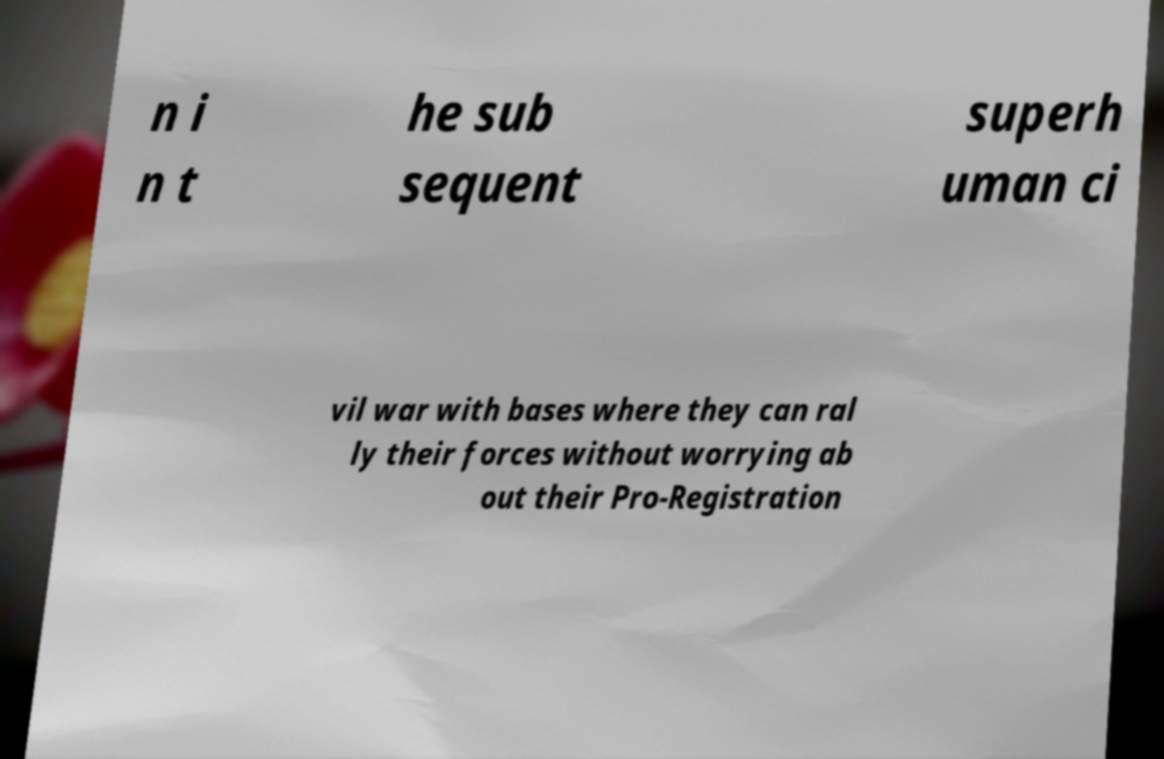For documentation purposes, I need the text within this image transcribed. Could you provide that? n i n t he sub sequent superh uman ci vil war with bases where they can ral ly their forces without worrying ab out their Pro-Registration 